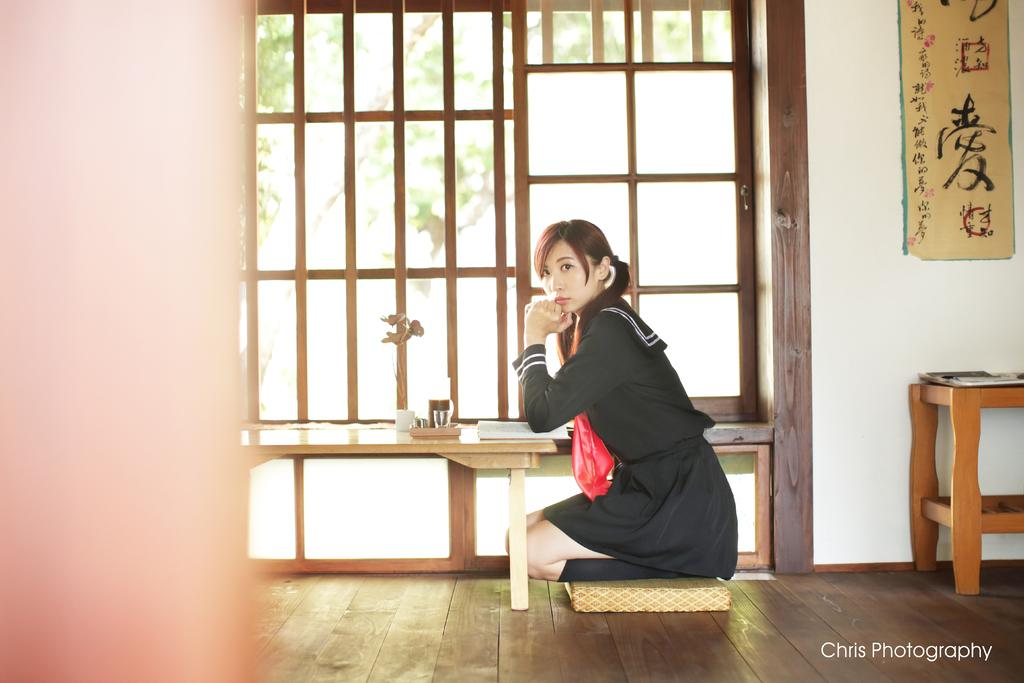Who is present in the image? There is a woman in the image. What is the woman doing in the image? The woman is seated on her knees. What can be seen on the table in the image? There is a book on the table. What is on the wall in the image? There is a hoarding on the wall. What type of cord is being used to wash the hoarding in the image? There is no cord or washing activity present in the image. The hoarding is simply displayed on the wall. 